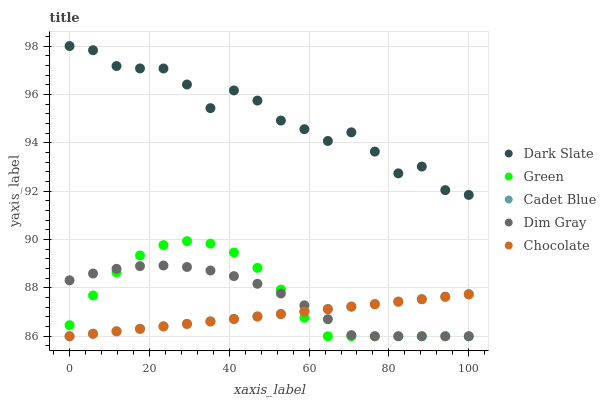Does Chocolate have the minimum area under the curve?
Answer yes or no. Yes. Does Dark Slate have the maximum area under the curve?
Answer yes or no. Yes. Does Dim Gray have the minimum area under the curve?
Answer yes or no. No. Does Dim Gray have the maximum area under the curve?
Answer yes or no. No. Is Chocolate the smoothest?
Answer yes or no. Yes. Is Dark Slate the roughest?
Answer yes or no. Yes. Is Dim Gray the smoothest?
Answer yes or no. No. Is Dim Gray the roughest?
Answer yes or no. No. Does Dim Gray have the lowest value?
Answer yes or no. Yes. Does Dark Slate have the highest value?
Answer yes or no. Yes. Does Dim Gray have the highest value?
Answer yes or no. No. Is Cadet Blue less than Dark Slate?
Answer yes or no. Yes. Is Dark Slate greater than Green?
Answer yes or no. Yes. Does Green intersect Dim Gray?
Answer yes or no. Yes. Is Green less than Dim Gray?
Answer yes or no. No. Is Green greater than Dim Gray?
Answer yes or no. No. Does Cadet Blue intersect Dark Slate?
Answer yes or no. No. 